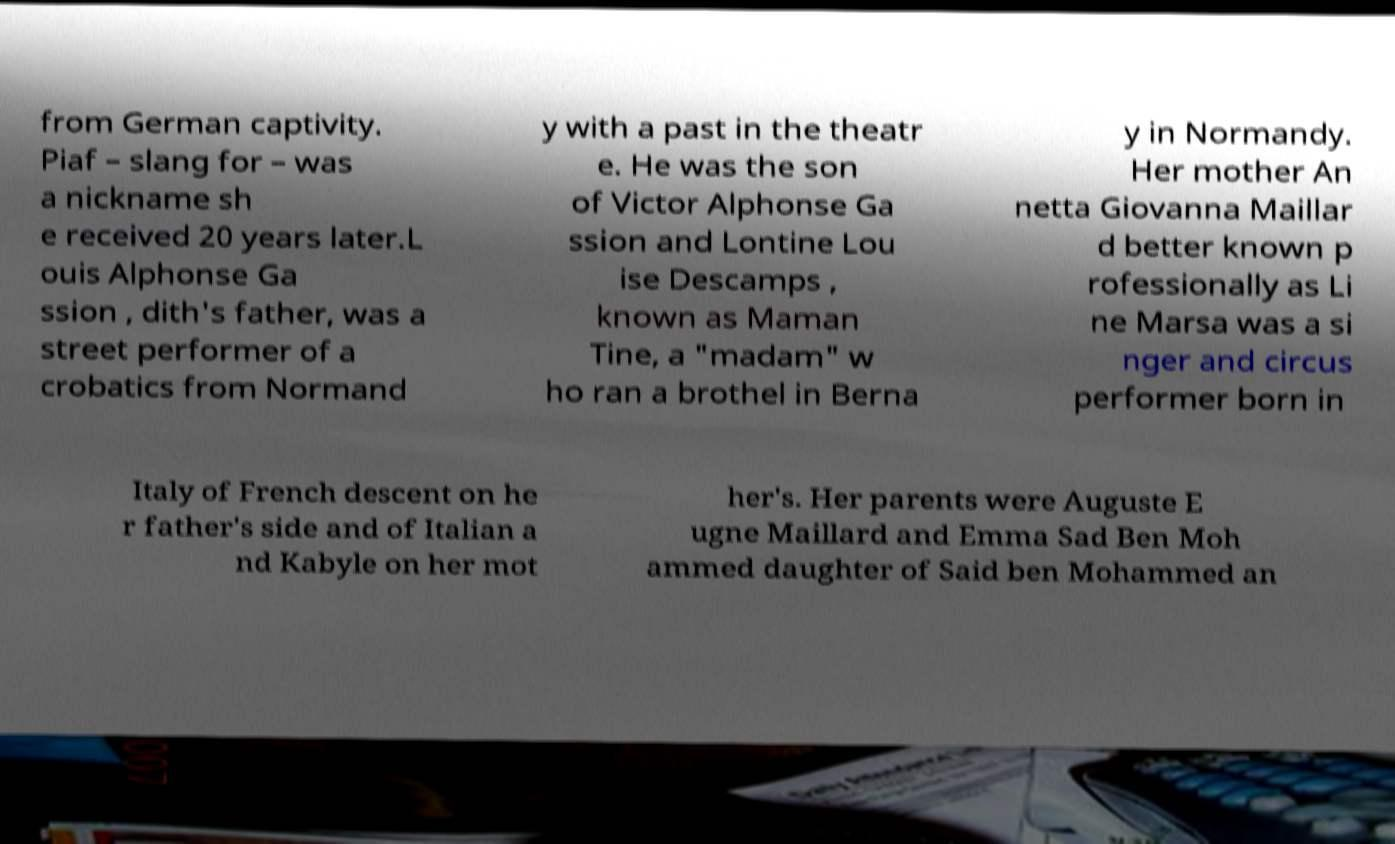There's text embedded in this image that I need extracted. Can you transcribe it verbatim? from German captivity. Piaf – slang for – was a nickname sh e received 20 years later.L ouis Alphonse Ga ssion , dith's father, was a street performer of a crobatics from Normand y with a past in the theatr e. He was the son of Victor Alphonse Ga ssion and Lontine Lou ise Descamps , known as Maman Tine, a "madam" w ho ran a brothel in Berna y in Normandy. Her mother An netta Giovanna Maillar d better known p rofessionally as Li ne Marsa was a si nger and circus performer born in Italy of French descent on he r father's side and of Italian a nd Kabyle on her mot her's. Her parents were Auguste E ugne Maillard and Emma Sad Ben Moh ammed daughter of Said ben Mohammed an 